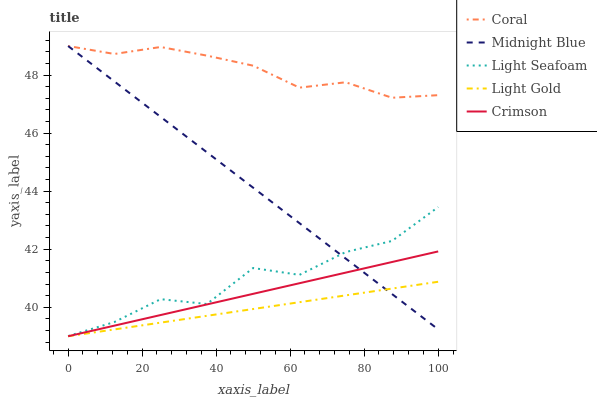Does Light Gold have the minimum area under the curve?
Answer yes or no. Yes. Does Coral have the maximum area under the curve?
Answer yes or no. Yes. Does Light Seafoam have the minimum area under the curve?
Answer yes or no. No. Does Light Seafoam have the maximum area under the curve?
Answer yes or no. No. Is Crimson the smoothest?
Answer yes or no. Yes. Is Light Seafoam the roughest?
Answer yes or no. Yes. Is Coral the smoothest?
Answer yes or no. No. Is Coral the roughest?
Answer yes or no. No. Does Light Seafoam have the lowest value?
Answer yes or no. No. Does Midnight Blue have the highest value?
Answer yes or no. Yes. Does Light Seafoam have the highest value?
Answer yes or no. No. Is Light Seafoam less than Coral?
Answer yes or no. Yes. Is Coral greater than Crimson?
Answer yes or no. Yes. Does Light Seafoam intersect Midnight Blue?
Answer yes or no. Yes. Is Light Seafoam less than Midnight Blue?
Answer yes or no. No. Is Light Seafoam greater than Midnight Blue?
Answer yes or no. No. Does Light Seafoam intersect Coral?
Answer yes or no. No. 